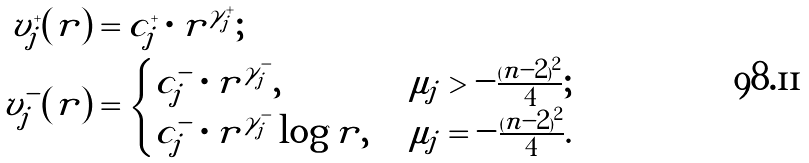<formula> <loc_0><loc_0><loc_500><loc_500>v _ { j } ^ { + } ( r ) & = c _ { j } ^ { + } \cdot r ^ { \gamma _ { j } ^ { + } } ; \\ v _ { j } ^ { - } ( r ) & = \begin{cases} c _ { j } ^ { - } \cdot r ^ { \gamma _ { j } ^ { - } } , & \ \mu _ { j } > - \frac { ( n - 2 ) ^ { 2 } } { 4 } ; \\ c _ { j } ^ { - } \cdot r ^ { \gamma _ { j } ^ { - } } \log r , & \ \mu _ { j } = - \frac { ( n - 2 ) ^ { 2 } } { 4 } . \end{cases}</formula> 